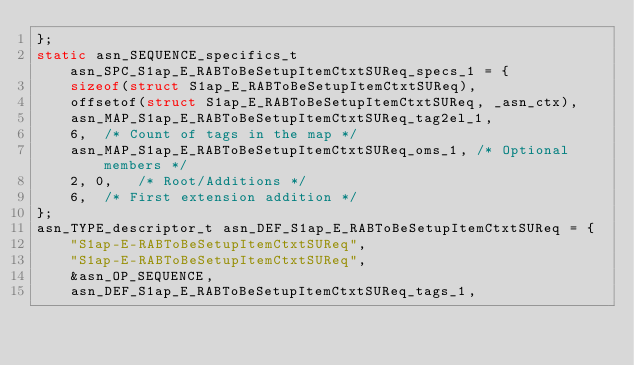Convert code to text. <code><loc_0><loc_0><loc_500><loc_500><_C_>};
static asn_SEQUENCE_specifics_t asn_SPC_S1ap_E_RABToBeSetupItemCtxtSUReq_specs_1 = {
	sizeof(struct S1ap_E_RABToBeSetupItemCtxtSUReq),
	offsetof(struct S1ap_E_RABToBeSetupItemCtxtSUReq, _asn_ctx),
	asn_MAP_S1ap_E_RABToBeSetupItemCtxtSUReq_tag2el_1,
	6,	/* Count of tags in the map */
	asn_MAP_S1ap_E_RABToBeSetupItemCtxtSUReq_oms_1,	/* Optional members */
	2, 0,	/* Root/Additions */
	6,	/* First extension addition */
};
asn_TYPE_descriptor_t asn_DEF_S1ap_E_RABToBeSetupItemCtxtSUReq = {
	"S1ap-E-RABToBeSetupItemCtxtSUReq",
	"S1ap-E-RABToBeSetupItemCtxtSUReq",
	&asn_OP_SEQUENCE,
	asn_DEF_S1ap_E_RABToBeSetupItemCtxtSUReq_tags_1,</code> 